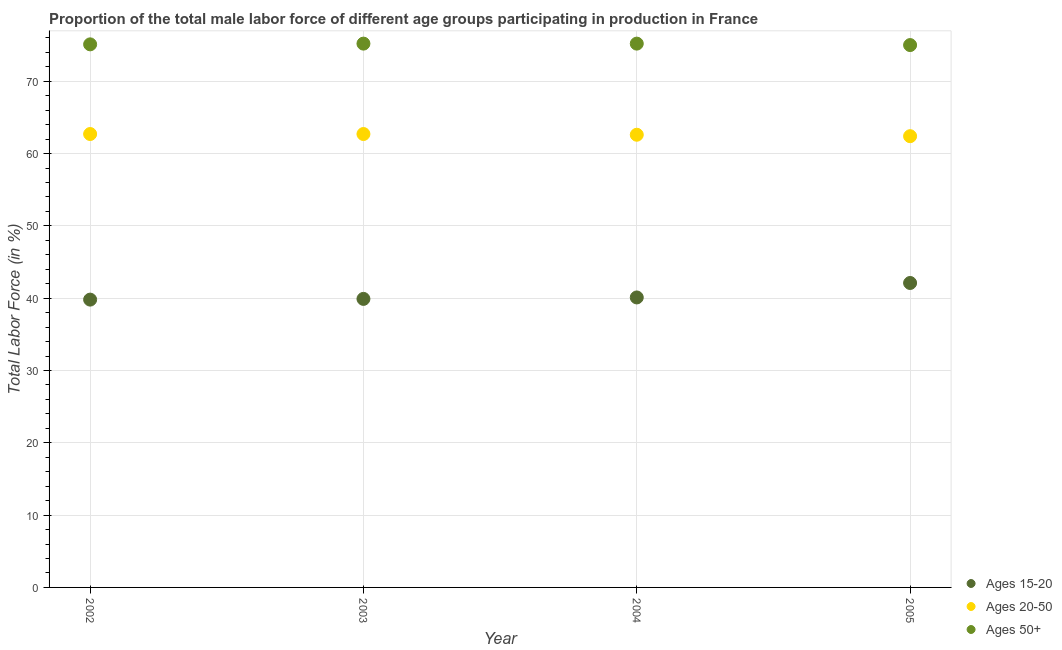Is the number of dotlines equal to the number of legend labels?
Offer a very short reply. Yes. What is the percentage of male labor force above age 50 in 2004?
Ensure brevity in your answer.  75.2. Across all years, what is the maximum percentage of male labor force within the age group 15-20?
Provide a short and direct response. 42.1. Across all years, what is the minimum percentage of male labor force within the age group 15-20?
Keep it short and to the point. 39.8. What is the total percentage of male labor force above age 50 in the graph?
Your answer should be very brief. 300.5. What is the difference between the percentage of male labor force within the age group 15-20 in 2003 and that in 2004?
Keep it short and to the point. -0.2. What is the difference between the percentage of male labor force within the age group 20-50 in 2002 and the percentage of male labor force within the age group 15-20 in 2005?
Make the answer very short. 20.6. What is the average percentage of male labor force within the age group 15-20 per year?
Your answer should be very brief. 40.47. In the year 2002, what is the difference between the percentage of male labor force within the age group 15-20 and percentage of male labor force above age 50?
Provide a short and direct response. -35.3. What is the ratio of the percentage of male labor force within the age group 20-50 in 2004 to that in 2005?
Make the answer very short. 1. Is the percentage of male labor force within the age group 20-50 in 2004 less than that in 2005?
Offer a very short reply. No. What is the difference between the highest and the lowest percentage of male labor force within the age group 20-50?
Your answer should be compact. 0.3. Is the percentage of male labor force above age 50 strictly greater than the percentage of male labor force within the age group 20-50 over the years?
Your response must be concise. Yes. How many dotlines are there?
Keep it short and to the point. 3. Are the values on the major ticks of Y-axis written in scientific E-notation?
Provide a succinct answer. No. Does the graph contain grids?
Offer a very short reply. Yes. How many legend labels are there?
Your answer should be very brief. 3. What is the title of the graph?
Provide a short and direct response. Proportion of the total male labor force of different age groups participating in production in France. What is the label or title of the Y-axis?
Ensure brevity in your answer.  Total Labor Force (in %). What is the Total Labor Force (in %) in Ages 15-20 in 2002?
Provide a succinct answer. 39.8. What is the Total Labor Force (in %) in Ages 20-50 in 2002?
Provide a short and direct response. 62.7. What is the Total Labor Force (in %) in Ages 50+ in 2002?
Provide a short and direct response. 75.1. What is the Total Labor Force (in %) in Ages 15-20 in 2003?
Your answer should be compact. 39.9. What is the Total Labor Force (in %) in Ages 20-50 in 2003?
Your response must be concise. 62.7. What is the Total Labor Force (in %) of Ages 50+ in 2003?
Offer a very short reply. 75.2. What is the Total Labor Force (in %) in Ages 15-20 in 2004?
Your response must be concise. 40.1. What is the Total Labor Force (in %) of Ages 20-50 in 2004?
Give a very brief answer. 62.6. What is the Total Labor Force (in %) in Ages 50+ in 2004?
Keep it short and to the point. 75.2. What is the Total Labor Force (in %) in Ages 15-20 in 2005?
Make the answer very short. 42.1. What is the Total Labor Force (in %) in Ages 20-50 in 2005?
Keep it short and to the point. 62.4. Across all years, what is the maximum Total Labor Force (in %) of Ages 15-20?
Provide a succinct answer. 42.1. Across all years, what is the maximum Total Labor Force (in %) in Ages 20-50?
Give a very brief answer. 62.7. Across all years, what is the maximum Total Labor Force (in %) of Ages 50+?
Make the answer very short. 75.2. Across all years, what is the minimum Total Labor Force (in %) in Ages 15-20?
Your answer should be very brief. 39.8. Across all years, what is the minimum Total Labor Force (in %) in Ages 20-50?
Ensure brevity in your answer.  62.4. What is the total Total Labor Force (in %) of Ages 15-20 in the graph?
Make the answer very short. 161.9. What is the total Total Labor Force (in %) in Ages 20-50 in the graph?
Give a very brief answer. 250.4. What is the total Total Labor Force (in %) of Ages 50+ in the graph?
Ensure brevity in your answer.  300.5. What is the difference between the Total Labor Force (in %) of Ages 20-50 in 2002 and that in 2003?
Your answer should be very brief. 0. What is the difference between the Total Labor Force (in %) of Ages 50+ in 2002 and that in 2003?
Offer a very short reply. -0.1. What is the difference between the Total Labor Force (in %) in Ages 50+ in 2002 and that in 2004?
Give a very brief answer. -0.1. What is the difference between the Total Labor Force (in %) of Ages 20-50 in 2002 and that in 2005?
Offer a very short reply. 0.3. What is the difference between the Total Labor Force (in %) in Ages 20-50 in 2003 and that in 2004?
Give a very brief answer. 0.1. What is the difference between the Total Labor Force (in %) of Ages 50+ in 2003 and that in 2004?
Offer a terse response. 0. What is the difference between the Total Labor Force (in %) of Ages 20-50 in 2003 and that in 2005?
Make the answer very short. 0.3. What is the difference between the Total Labor Force (in %) in Ages 50+ in 2003 and that in 2005?
Your response must be concise. 0.2. What is the difference between the Total Labor Force (in %) of Ages 15-20 in 2004 and that in 2005?
Your answer should be compact. -2. What is the difference between the Total Labor Force (in %) in Ages 15-20 in 2002 and the Total Labor Force (in %) in Ages 20-50 in 2003?
Offer a terse response. -22.9. What is the difference between the Total Labor Force (in %) of Ages 15-20 in 2002 and the Total Labor Force (in %) of Ages 50+ in 2003?
Your answer should be very brief. -35.4. What is the difference between the Total Labor Force (in %) in Ages 20-50 in 2002 and the Total Labor Force (in %) in Ages 50+ in 2003?
Provide a short and direct response. -12.5. What is the difference between the Total Labor Force (in %) in Ages 15-20 in 2002 and the Total Labor Force (in %) in Ages 20-50 in 2004?
Provide a succinct answer. -22.8. What is the difference between the Total Labor Force (in %) in Ages 15-20 in 2002 and the Total Labor Force (in %) in Ages 50+ in 2004?
Your answer should be compact. -35.4. What is the difference between the Total Labor Force (in %) in Ages 15-20 in 2002 and the Total Labor Force (in %) in Ages 20-50 in 2005?
Your answer should be compact. -22.6. What is the difference between the Total Labor Force (in %) of Ages 15-20 in 2002 and the Total Labor Force (in %) of Ages 50+ in 2005?
Your answer should be compact. -35.2. What is the difference between the Total Labor Force (in %) of Ages 15-20 in 2003 and the Total Labor Force (in %) of Ages 20-50 in 2004?
Ensure brevity in your answer.  -22.7. What is the difference between the Total Labor Force (in %) of Ages 15-20 in 2003 and the Total Labor Force (in %) of Ages 50+ in 2004?
Make the answer very short. -35.3. What is the difference between the Total Labor Force (in %) in Ages 20-50 in 2003 and the Total Labor Force (in %) in Ages 50+ in 2004?
Keep it short and to the point. -12.5. What is the difference between the Total Labor Force (in %) in Ages 15-20 in 2003 and the Total Labor Force (in %) in Ages 20-50 in 2005?
Give a very brief answer. -22.5. What is the difference between the Total Labor Force (in %) of Ages 15-20 in 2003 and the Total Labor Force (in %) of Ages 50+ in 2005?
Keep it short and to the point. -35.1. What is the difference between the Total Labor Force (in %) of Ages 20-50 in 2003 and the Total Labor Force (in %) of Ages 50+ in 2005?
Your answer should be very brief. -12.3. What is the difference between the Total Labor Force (in %) of Ages 15-20 in 2004 and the Total Labor Force (in %) of Ages 20-50 in 2005?
Keep it short and to the point. -22.3. What is the difference between the Total Labor Force (in %) of Ages 15-20 in 2004 and the Total Labor Force (in %) of Ages 50+ in 2005?
Your answer should be compact. -34.9. What is the average Total Labor Force (in %) of Ages 15-20 per year?
Give a very brief answer. 40.48. What is the average Total Labor Force (in %) in Ages 20-50 per year?
Provide a short and direct response. 62.6. What is the average Total Labor Force (in %) of Ages 50+ per year?
Your answer should be compact. 75.12. In the year 2002, what is the difference between the Total Labor Force (in %) in Ages 15-20 and Total Labor Force (in %) in Ages 20-50?
Your answer should be very brief. -22.9. In the year 2002, what is the difference between the Total Labor Force (in %) of Ages 15-20 and Total Labor Force (in %) of Ages 50+?
Give a very brief answer. -35.3. In the year 2003, what is the difference between the Total Labor Force (in %) in Ages 15-20 and Total Labor Force (in %) in Ages 20-50?
Provide a succinct answer. -22.8. In the year 2003, what is the difference between the Total Labor Force (in %) of Ages 15-20 and Total Labor Force (in %) of Ages 50+?
Make the answer very short. -35.3. In the year 2003, what is the difference between the Total Labor Force (in %) in Ages 20-50 and Total Labor Force (in %) in Ages 50+?
Keep it short and to the point. -12.5. In the year 2004, what is the difference between the Total Labor Force (in %) in Ages 15-20 and Total Labor Force (in %) in Ages 20-50?
Give a very brief answer. -22.5. In the year 2004, what is the difference between the Total Labor Force (in %) in Ages 15-20 and Total Labor Force (in %) in Ages 50+?
Ensure brevity in your answer.  -35.1. In the year 2005, what is the difference between the Total Labor Force (in %) of Ages 15-20 and Total Labor Force (in %) of Ages 20-50?
Keep it short and to the point. -20.3. In the year 2005, what is the difference between the Total Labor Force (in %) of Ages 15-20 and Total Labor Force (in %) of Ages 50+?
Give a very brief answer. -32.9. In the year 2005, what is the difference between the Total Labor Force (in %) in Ages 20-50 and Total Labor Force (in %) in Ages 50+?
Provide a succinct answer. -12.6. What is the ratio of the Total Labor Force (in %) in Ages 15-20 in 2002 to that in 2003?
Make the answer very short. 1. What is the ratio of the Total Labor Force (in %) of Ages 15-20 in 2002 to that in 2005?
Give a very brief answer. 0.95. What is the ratio of the Total Labor Force (in %) in Ages 20-50 in 2002 to that in 2005?
Make the answer very short. 1. What is the ratio of the Total Labor Force (in %) of Ages 50+ in 2002 to that in 2005?
Keep it short and to the point. 1. What is the ratio of the Total Labor Force (in %) in Ages 15-20 in 2003 to that in 2004?
Make the answer very short. 0.99. What is the ratio of the Total Labor Force (in %) of Ages 20-50 in 2003 to that in 2004?
Offer a terse response. 1. What is the ratio of the Total Labor Force (in %) of Ages 15-20 in 2003 to that in 2005?
Provide a succinct answer. 0.95. What is the ratio of the Total Labor Force (in %) in Ages 15-20 in 2004 to that in 2005?
Ensure brevity in your answer.  0.95. What is the ratio of the Total Labor Force (in %) in Ages 50+ in 2004 to that in 2005?
Your response must be concise. 1. What is the difference between the highest and the lowest Total Labor Force (in %) in Ages 20-50?
Provide a short and direct response. 0.3. What is the difference between the highest and the lowest Total Labor Force (in %) in Ages 50+?
Your answer should be very brief. 0.2. 